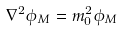Convert formula to latex. <formula><loc_0><loc_0><loc_500><loc_500>\nabla ^ { 2 } \phi _ { M } = m _ { 0 } ^ { 2 } \phi _ { M }</formula> 